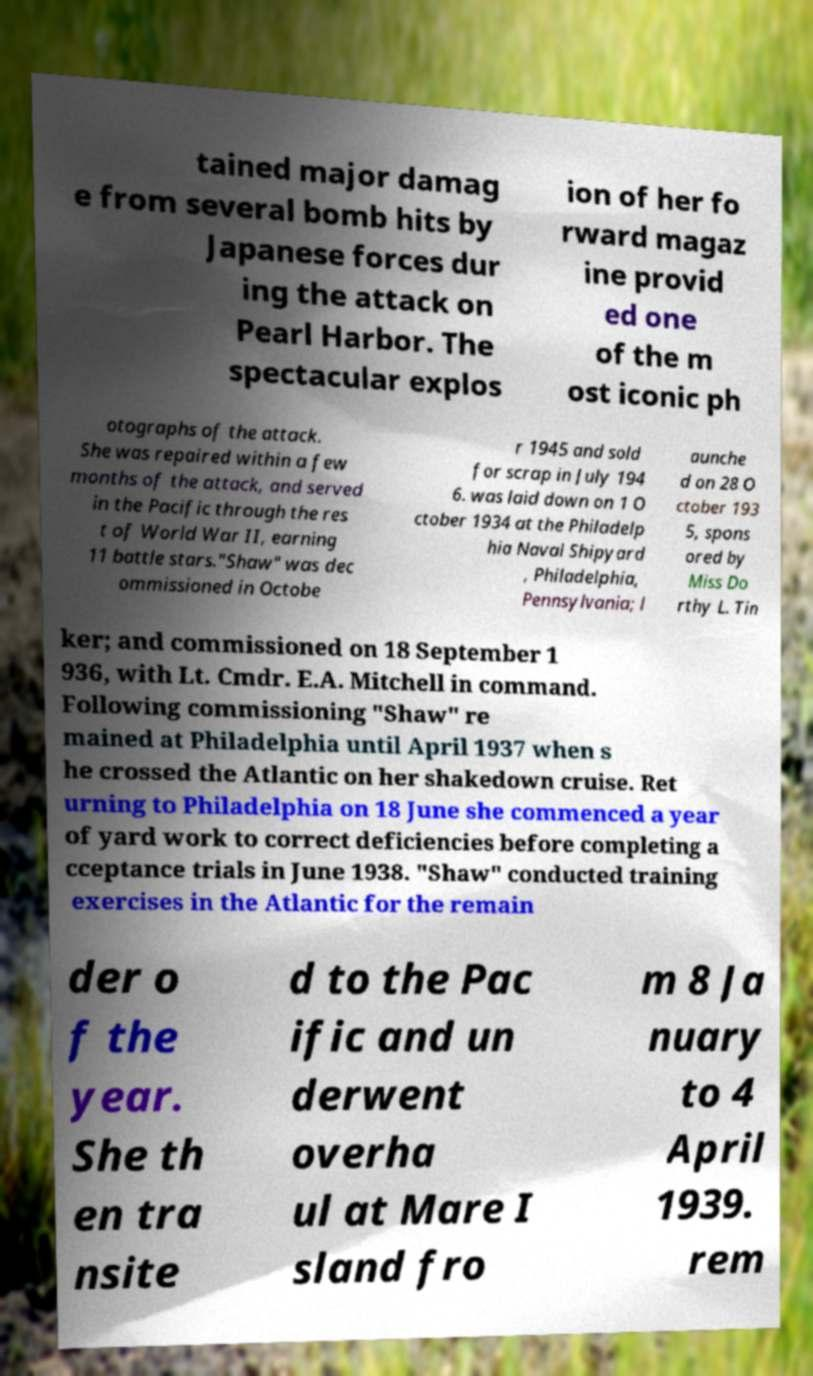Please identify and transcribe the text found in this image. tained major damag e from several bomb hits by Japanese forces dur ing the attack on Pearl Harbor. The spectacular explos ion of her fo rward magaz ine provid ed one of the m ost iconic ph otographs of the attack. She was repaired within a few months of the attack, and served in the Pacific through the res t of World War II, earning 11 battle stars."Shaw" was dec ommissioned in Octobe r 1945 and sold for scrap in July 194 6. was laid down on 1 O ctober 1934 at the Philadelp hia Naval Shipyard , Philadelphia, Pennsylvania; l aunche d on 28 O ctober 193 5, spons ored by Miss Do rthy L. Tin ker; and commissioned on 18 September 1 936, with Lt. Cmdr. E.A. Mitchell in command. Following commissioning "Shaw" re mained at Philadelphia until April 1937 when s he crossed the Atlantic on her shakedown cruise. Ret urning to Philadelphia on 18 June she commenced a year of yard work to correct deficiencies before completing a cceptance trials in June 1938. "Shaw" conducted training exercises in the Atlantic for the remain der o f the year. She th en tra nsite d to the Pac ific and un derwent overha ul at Mare I sland fro m 8 Ja nuary to 4 April 1939. rem 